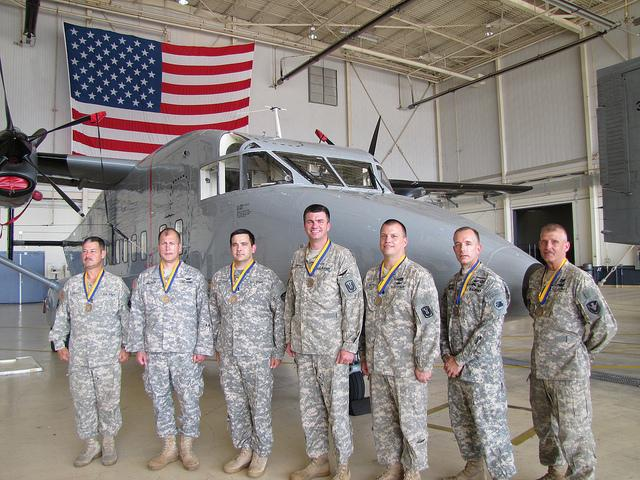How do the people know each other? military 